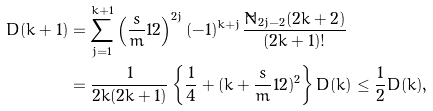<formula> <loc_0><loc_0><loc_500><loc_500>D ( k + 1 ) & = \sum _ { j = 1 } ^ { k + 1 } \left ( \frac { s } { m } { 1 } { 2 } \right ) ^ { 2 j } ( - 1 ) ^ { k + j } \frac { \tilde { N } _ { 2 j - 2 } ( 2 k + 2 ) } { ( 2 k + 1 ) ! } \\ & = \frac { 1 } { 2 k ( 2 k + 1 ) } \left \{ \frac { 1 } { 4 } + ( k + \frac { s } { m } { 1 } { 2 } ) ^ { 2 } \right \} D ( k ) \leq \frac { 1 } { 2 } D ( k ) ,</formula> 